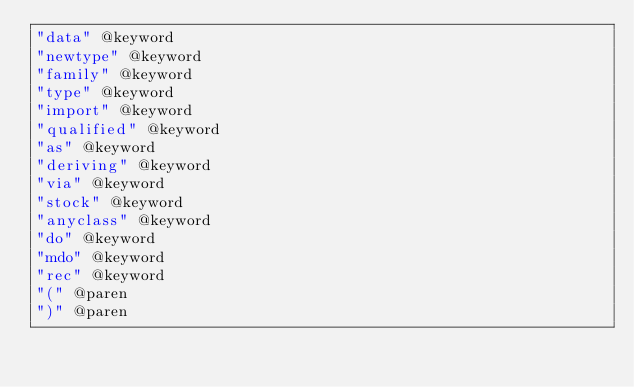Convert code to text. <code><loc_0><loc_0><loc_500><loc_500><_Scheme_>"data" @keyword
"newtype" @keyword
"family" @keyword
"type" @keyword
"import" @keyword
"qualified" @keyword
"as" @keyword
"deriving" @keyword
"via" @keyword
"stock" @keyword
"anyclass" @keyword
"do" @keyword
"mdo" @keyword
"rec" @keyword
"(" @paren
")" @paren
</code> 